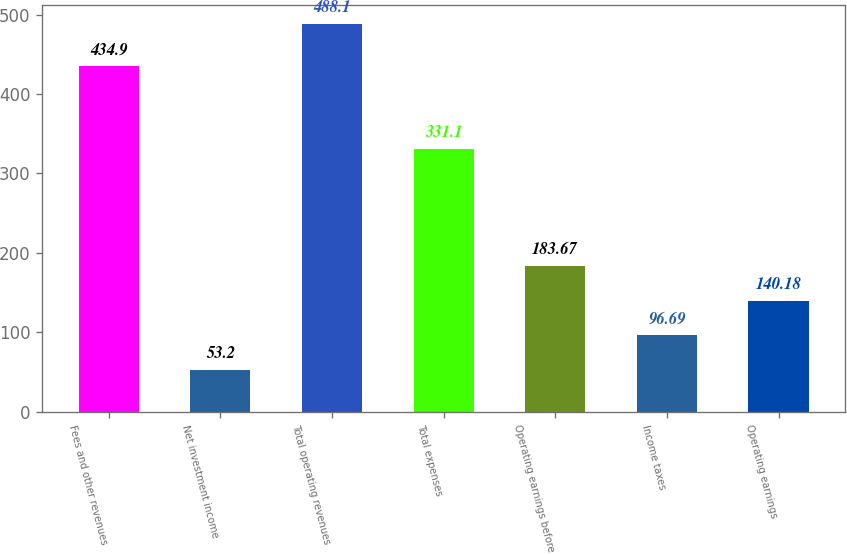Convert chart. <chart><loc_0><loc_0><loc_500><loc_500><bar_chart><fcel>Fees and other revenues<fcel>Net investment income<fcel>Total operating revenues<fcel>Total expenses<fcel>Operating earnings before<fcel>Income taxes<fcel>Operating earnings<nl><fcel>434.9<fcel>53.2<fcel>488.1<fcel>331.1<fcel>183.67<fcel>96.69<fcel>140.18<nl></chart> 